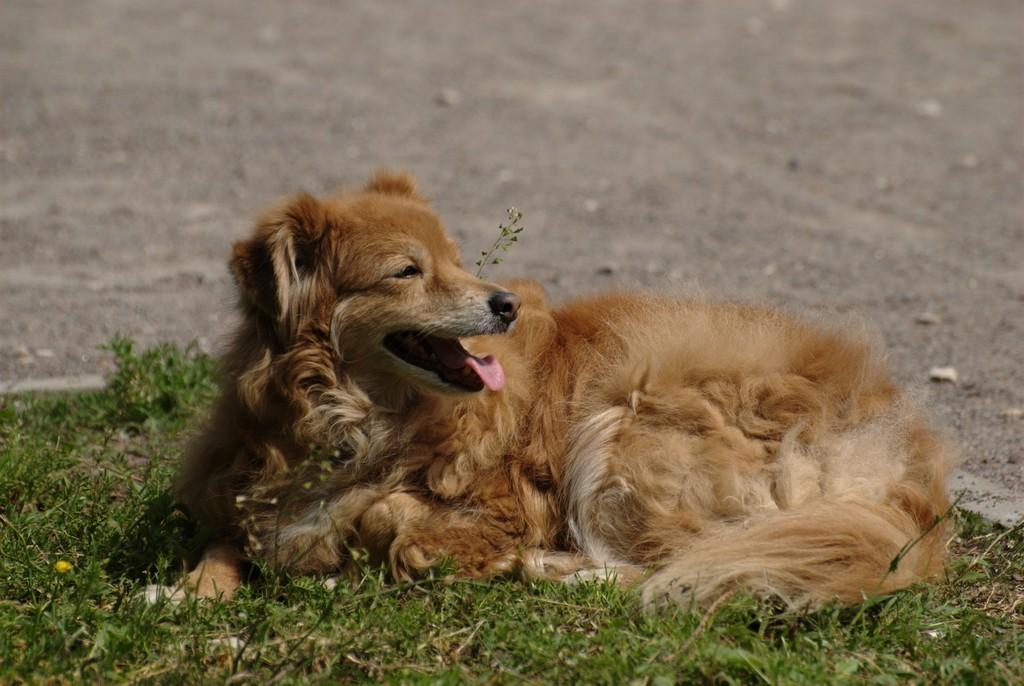In one or two sentences, can you explain what this image depicts? In this image a dog is sitting on grassland. Top of the image there is land. 